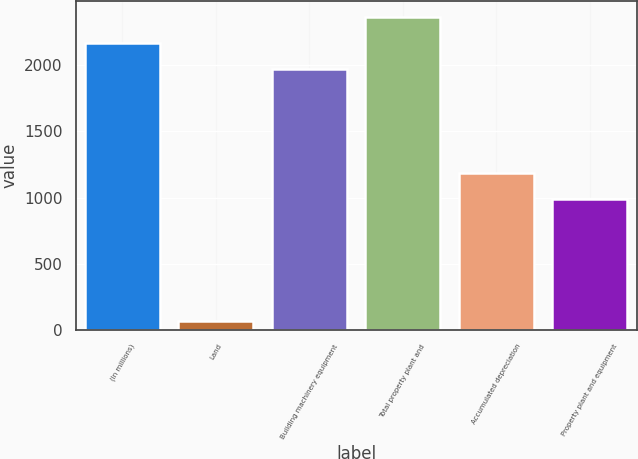Convert chart to OTSL. <chart><loc_0><loc_0><loc_500><loc_500><bar_chart><fcel>(In millions)<fcel>Land<fcel>Building machinery equipment<fcel>Total property plant and<fcel>Accumulated depreciation<fcel>Property plant and equipment<nl><fcel>2170.3<fcel>70<fcel>1973<fcel>2367.6<fcel>1188.3<fcel>991<nl></chart> 